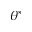Convert formula to latex. <formula><loc_0><loc_0><loc_500><loc_500>\theta ^ { * }</formula> 